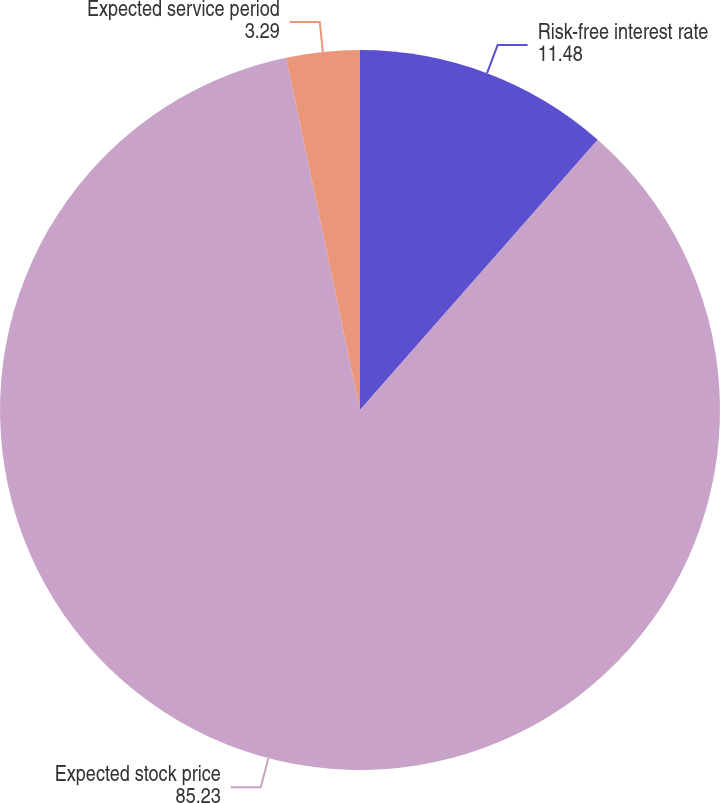Convert chart to OTSL. <chart><loc_0><loc_0><loc_500><loc_500><pie_chart><fcel>Risk-free interest rate<fcel>Expected stock price<fcel>Expected service period<nl><fcel>11.48%<fcel>85.23%<fcel>3.29%<nl></chart> 